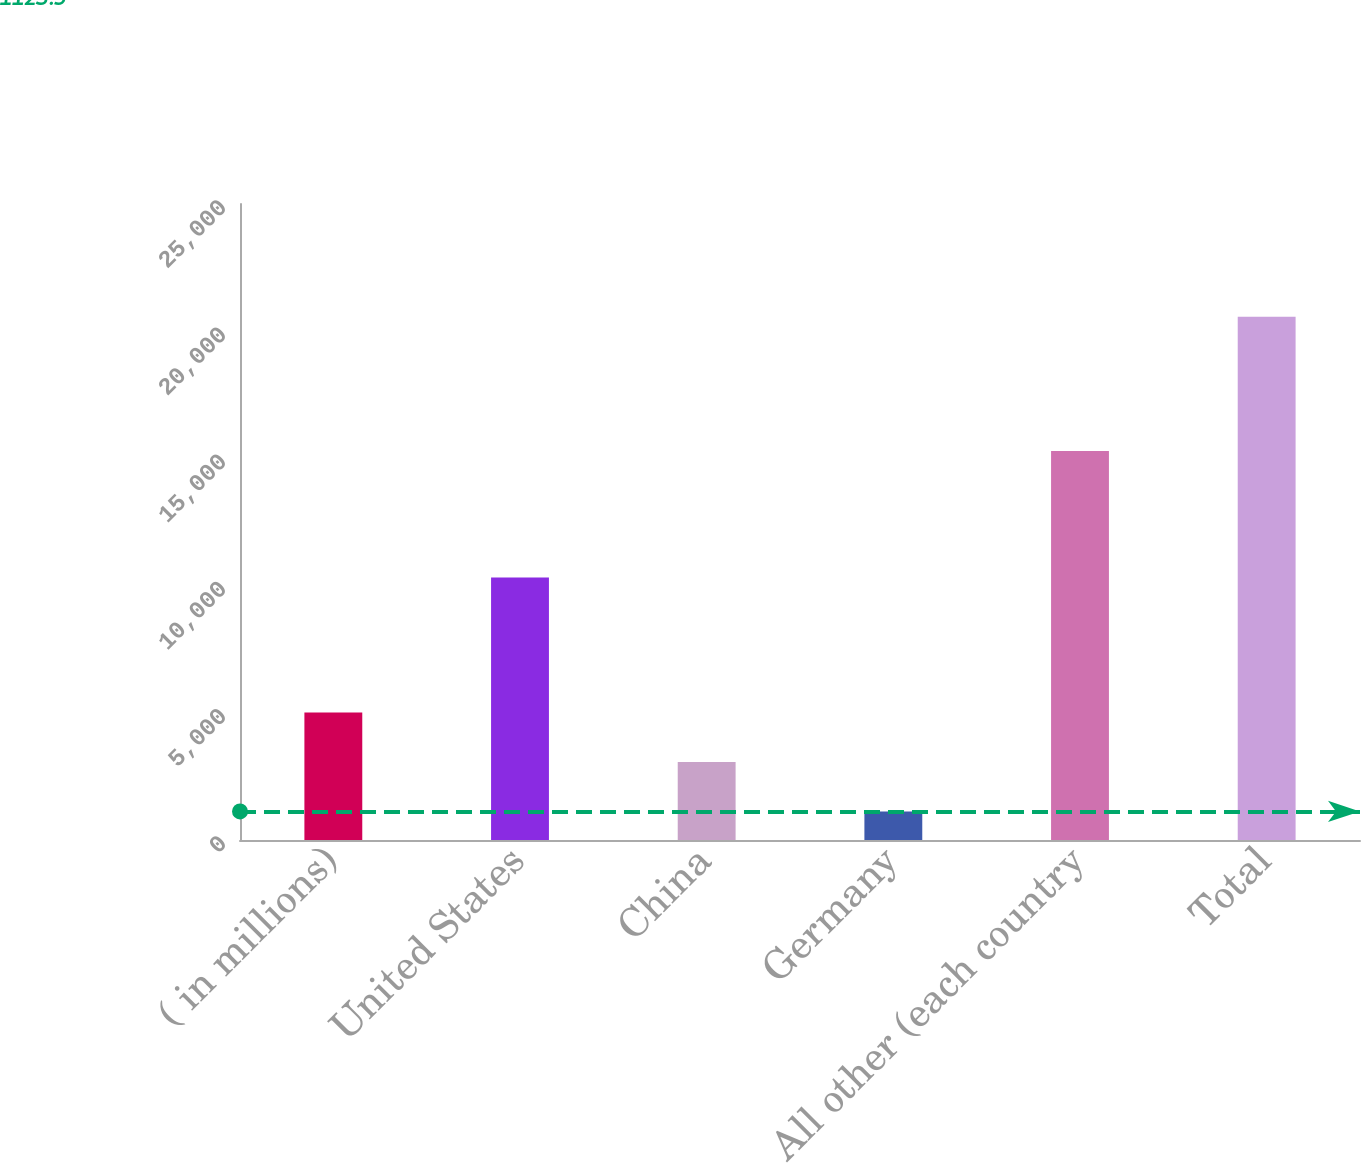Convert chart to OTSL. <chart><loc_0><loc_0><loc_500><loc_500><bar_chart><fcel>( in millions)<fcel>United States<fcel>China<fcel>Germany<fcel>All other (each country<fcel>Total<nl><fcel>5011.42<fcel>10321<fcel>3067.46<fcel>1123.5<fcel>15286.7<fcel>20563.1<nl></chart> 